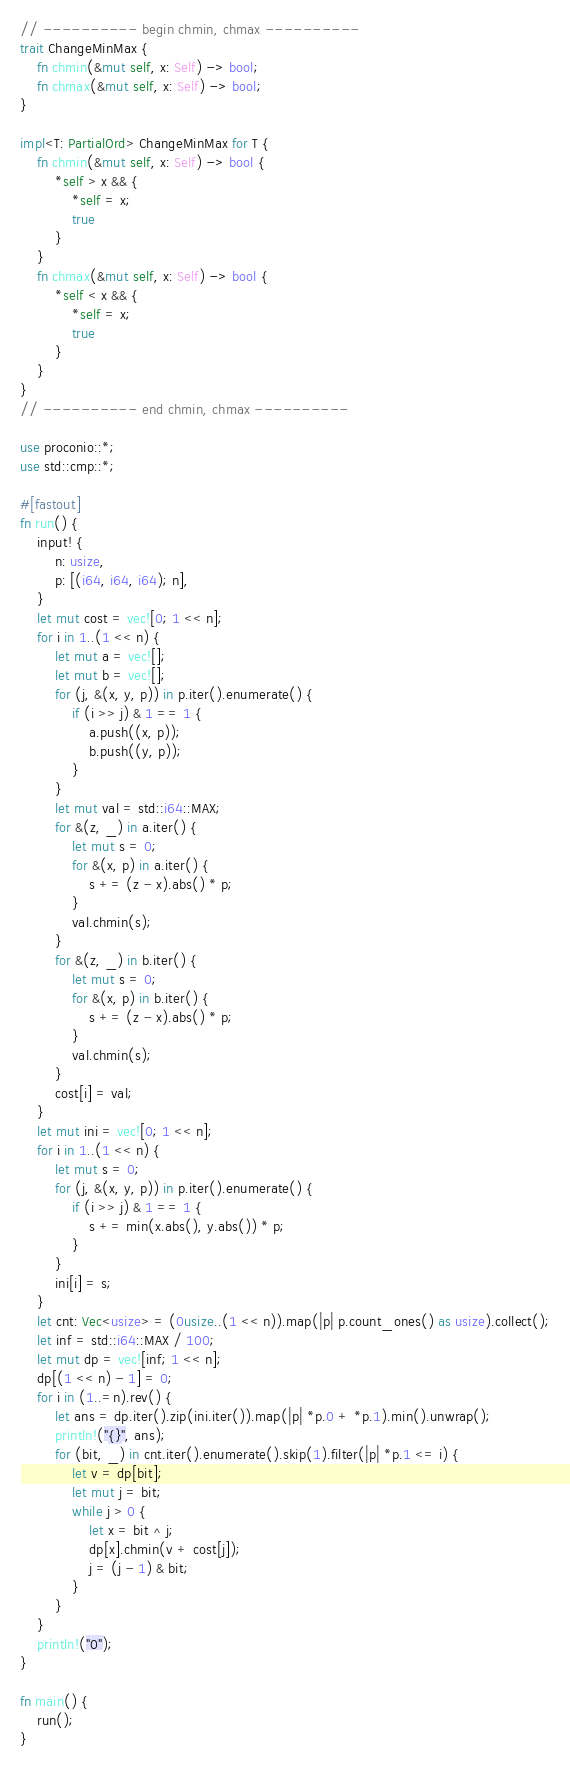<code> <loc_0><loc_0><loc_500><loc_500><_Rust_>// ---------- begin chmin, chmax ----------
trait ChangeMinMax {
    fn chmin(&mut self, x: Self) -> bool;
    fn chmax(&mut self, x: Self) -> bool;
}

impl<T: PartialOrd> ChangeMinMax for T {
    fn chmin(&mut self, x: Self) -> bool {
        *self > x && {
            *self = x;
            true
        }
    }
    fn chmax(&mut self, x: Self) -> bool {
        *self < x && {
            *self = x;
            true
        }
    }
}
// ---------- end chmin, chmax ----------

use proconio::*;
use std::cmp::*;

#[fastout]
fn run() {
    input! {
        n: usize,
        p: [(i64, i64, i64); n],
    }
    let mut cost = vec![0; 1 << n];
    for i in 1..(1 << n) {
        let mut a = vec![];
        let mut b = vec![];
        for (j, &(x, y, p)) in p.iter().enumerate() {
            if (i >> j) & 1 == 1 {
                a.push((x, p));
                b.push((y, p));
            }
        }
        let mut val = std::i64::MAX;
        for &(z, _) in a.iter() {
            let mut s = 0;
            for &(x, p) in a.iter() {
                s += (z - x).abs() * p;
            }
            val.chmin(s);
        }
        for &(z, _) in b.iter() {
            let mut s = 0;
            for &(x, p) in b.iter() {
                s += (z - x).abs() * p;
            }
            val.chmin(s);
        }
        cost[i] = val;
    }
    let mut ini = vec![0; 1 << n];
    for i in 1..(1 << n) {
        let mut s = 0;
        for (j, &(x, y, p)) in p.iter().enumerate() {
            if (i >> j) & 1 == 1 {
                s += min(x.abs(), y.abs()) * p;
            }
        }
        ini[i] = s;
    }
    let cnt: Vec<usize> = (0usize..(1 << n)).map(|p| p.count_ones() as usize).collect();
    let inf = std::i64::MAX / 100;
    let mut dp = vec![inf; 1 << n];
    dp[(1 << n) - 1] = 0;
    for i in (1..=n).rev() {
        let ans = dp.iter().zip(ini.iter()).map(|p| *p.0 + *p.1).min().unwrap();
        println!("{}", ans);
        for (bit, _) in cnt.iter().enumerate().skip(1).filter(|p| *p.1 <= i) {
            let v = dp[bit];
            let mut j = bit;
            while j > 0 {
                let x = bit ^ j;
                dp[x].chmin(v + cost[j]);
                j = (j - 1) & bit;
            }
        }
    }
    println!("0");
}

fn main() {
    run();
}
</code> 